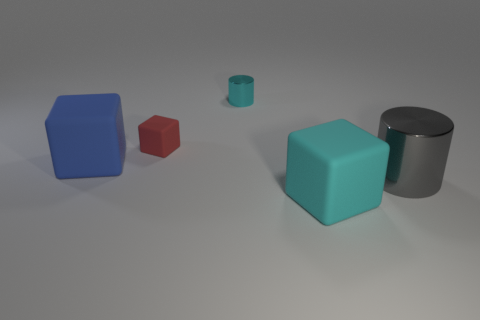Add 1 cyan shiny objects. How many objects exist? 6 Subtract all cylinders. How many objects are left? 3 Subtract 0 red cylinders. How many objects are left? 5 Subtract all tiny rubber things. Subtract all tiny shiny things. How many objects are left? 3 Add 3 big metal cylinders. How many big metal cylinders are left? 4 Add 5 purple rubber blocks. How many purple rubber blocks exist? 5 